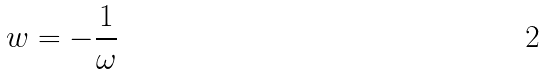<formula> <loc_0><loc_0><loc_500><loc_500>w = - \frac { 1 } { \omega }</formula> 